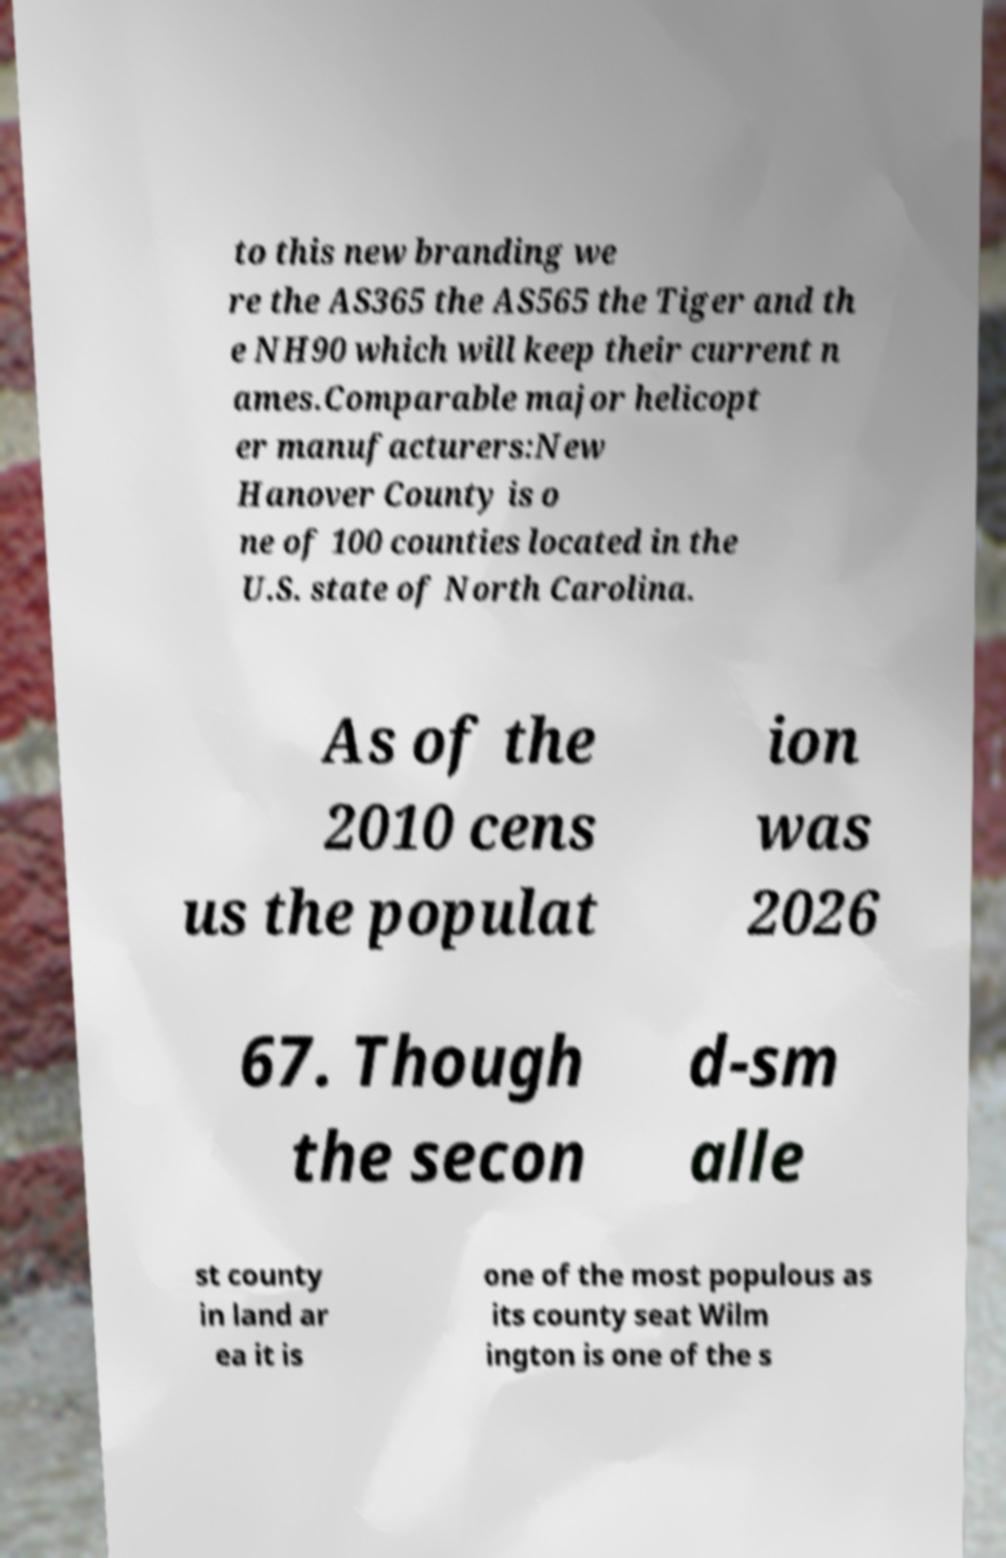There's text embedded in this image that I need extracted. Can you transcribe it verbatim? to this new branding we re the AS365 the AS565 the Tiger and th e NH90 which will keep their current n ames.Comparable major helicopt er manufacturers:New Hanover County is o ne of 100 counties located in the U.S. state of North Carolina. As of the 2010 cens us the populat ion was 2026 67. Though the secon d-sm alle st county in land ar ea it is one of the most populous as its county seat Wilm ington is one of the s 